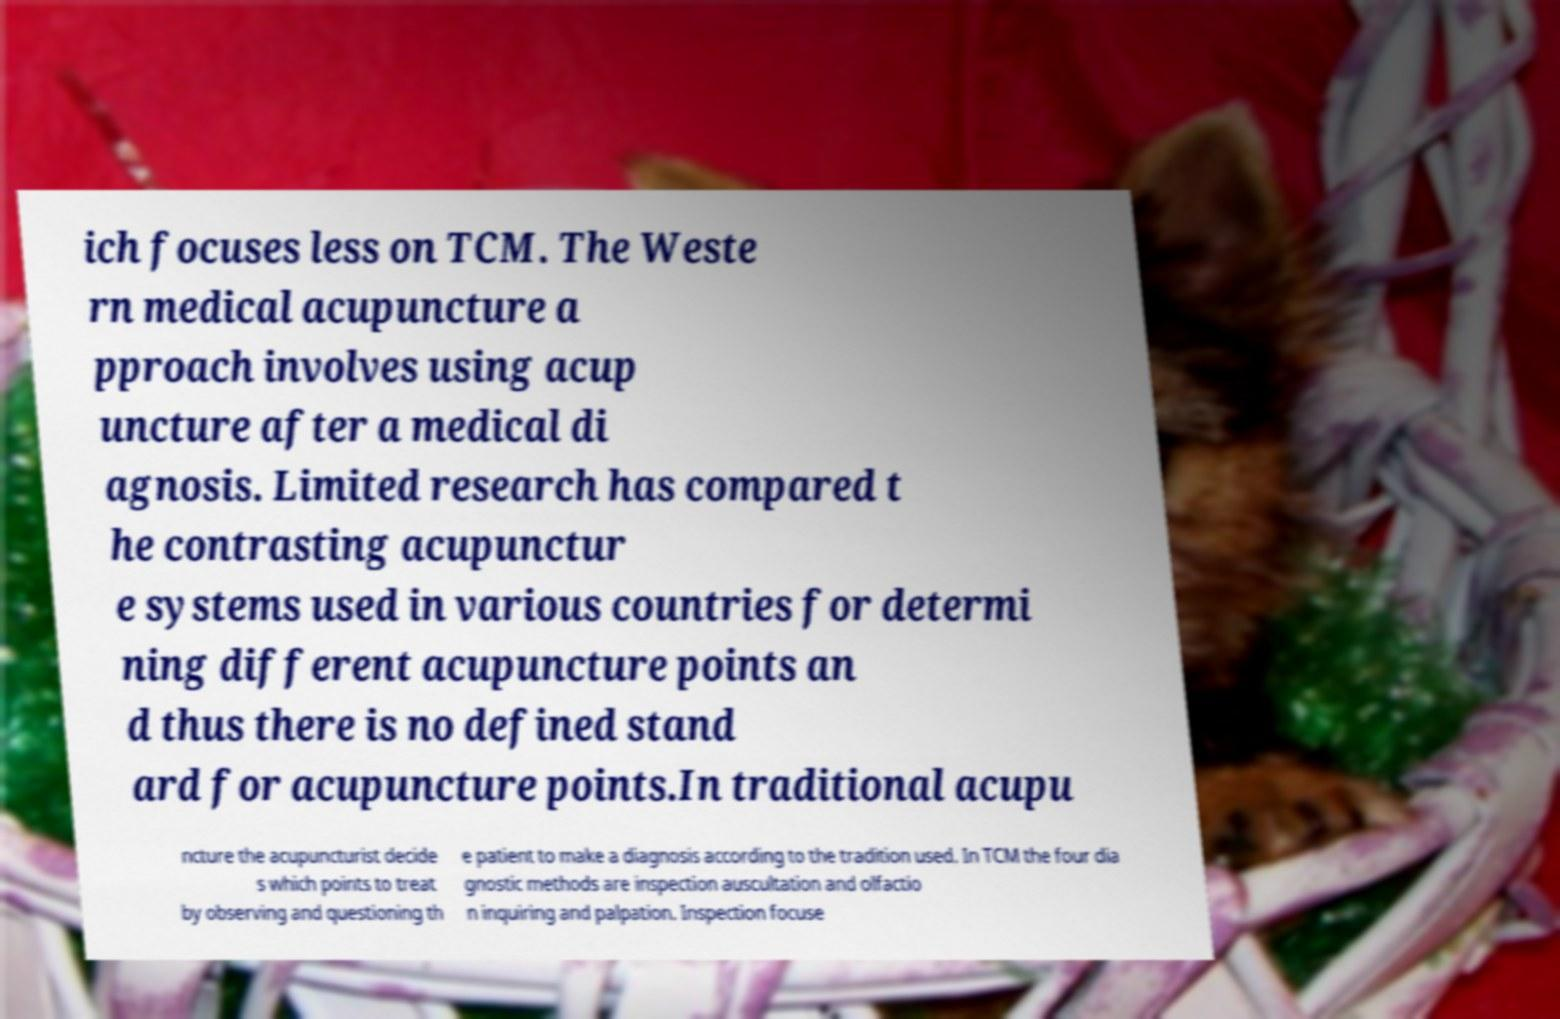What messages or text are displayed in this image? I need them in a readable, typed format. ich focuses less on TCM. The Weste rn medical acupuncture a pproach involves using acup uncture after a medical di agnosis. Limited research has compared t he contrasting acupunctur e systems used in various countries for determi ning different acupuncture points an d thus there is no defined stand ard for acupuncture points.In traditional acupu ncture the acupuncturist decide s which points to treat by observing and questioning th e patient to make a diagnosis according to the tradition used. In TCM the four dia gnostic methods are inspection auscultation and olfactio n inquiring and palpation. Inspection focuse 